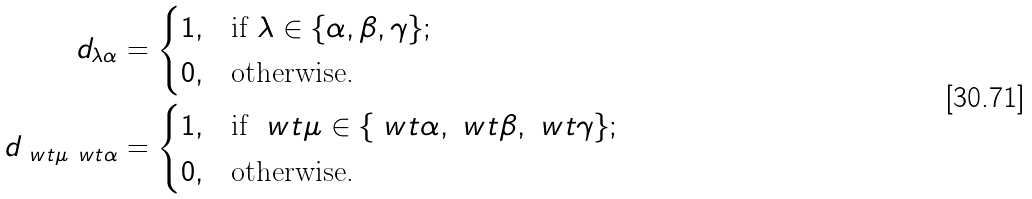<formula> <loc_0><loc_0><loc_500><loc_500>d _ { \lambda \alpha } & = \begin{cases} 1 , & \text {if } \lambda \in \{ \alpha , \beta , \gamma \} ; \\ 0 , & \text {otherwise.} \end{cases} \\ d _ { \ w t { \mu } \ w t { \alpha } } & = \begin{cases} 1 , & \text {if } \ w t { \mu } \in \{ \ w t { \alpha } , \ w t { \beta } , \ w t { \gamma } \} ; \\ 0 , & \text {otherwise.} \end{cases}</formula> 